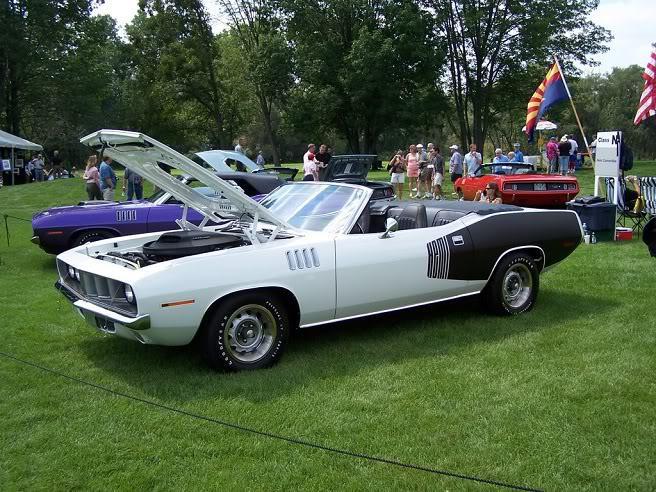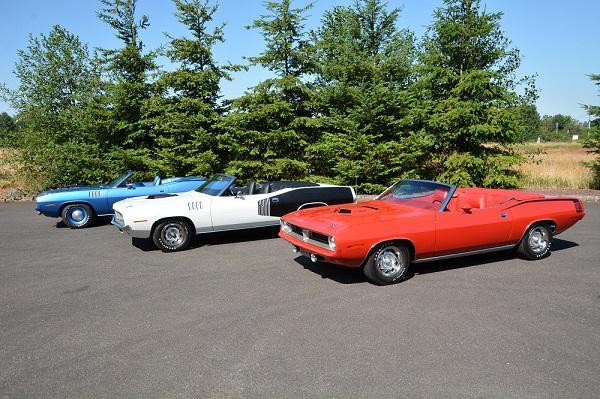The first image is the image on the left, the second image is the image on the right. Evaluate the accuracy of this statement regarding the images: "Two predominantly white convertibles have the tops down, one facing towards the front and one to the back.". Is it true? Answer yes or no. No. 